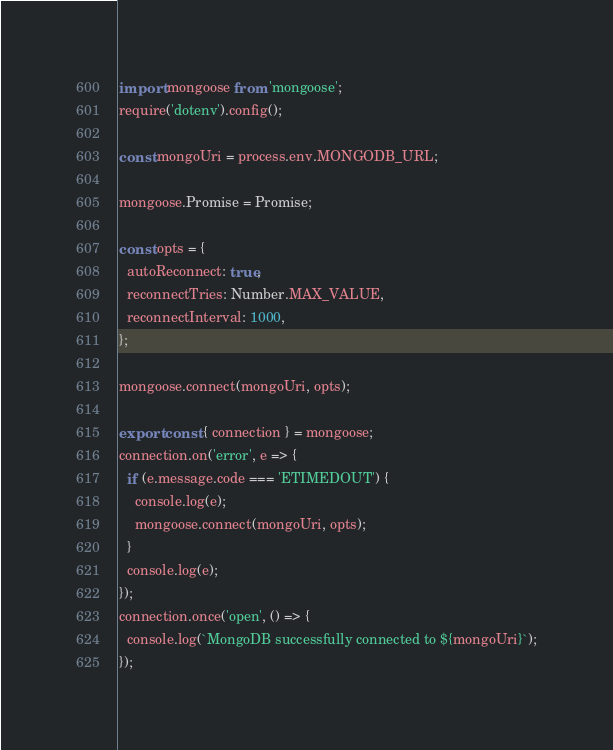Convert code to text. <code><loc_0><loc_0><loc_500><loc_500><_JavaScript_>import mongoose from 'mongoose';
require('dotenv').config();

const mongoUri = process.env.MONGODB_URL;

mongoose.Promise = Promise;

const opts = {
  autoReconnect: true,
  reconnectTries: Number.MAX_VALUE,
  reconnectInterval: 1000,
};

mongoose.connect(mongoUri, opts);

export const { connection } = mongoose;
connection.on('error', e => {
  if (e.message.code === 'ETIMEDOUT') {
    console.log(e);
    mongoose.connect(mongoUri, opts);
  }
  console.log(e);
});
connection.once('open', () => {
  console.log(`MongoDB successfully connected to ${mongoUri}`);
});
</code> 